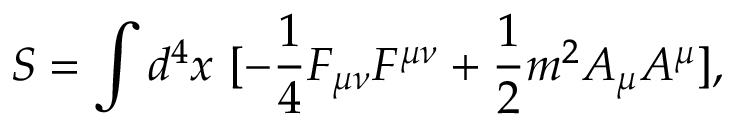Convert formula to latex. <formula><loc_0><loc_0><loc_500><loc_500>S = \int d ^ { 4 } x \ [ - \frac { 1 } { 4 } F _ { \mu \nu } F ^ { \mu \nu } + \frac { 1 } { 2 } m ^ { 2 } A _ { \mu } A ^ { \mu } ] ,</formula> 